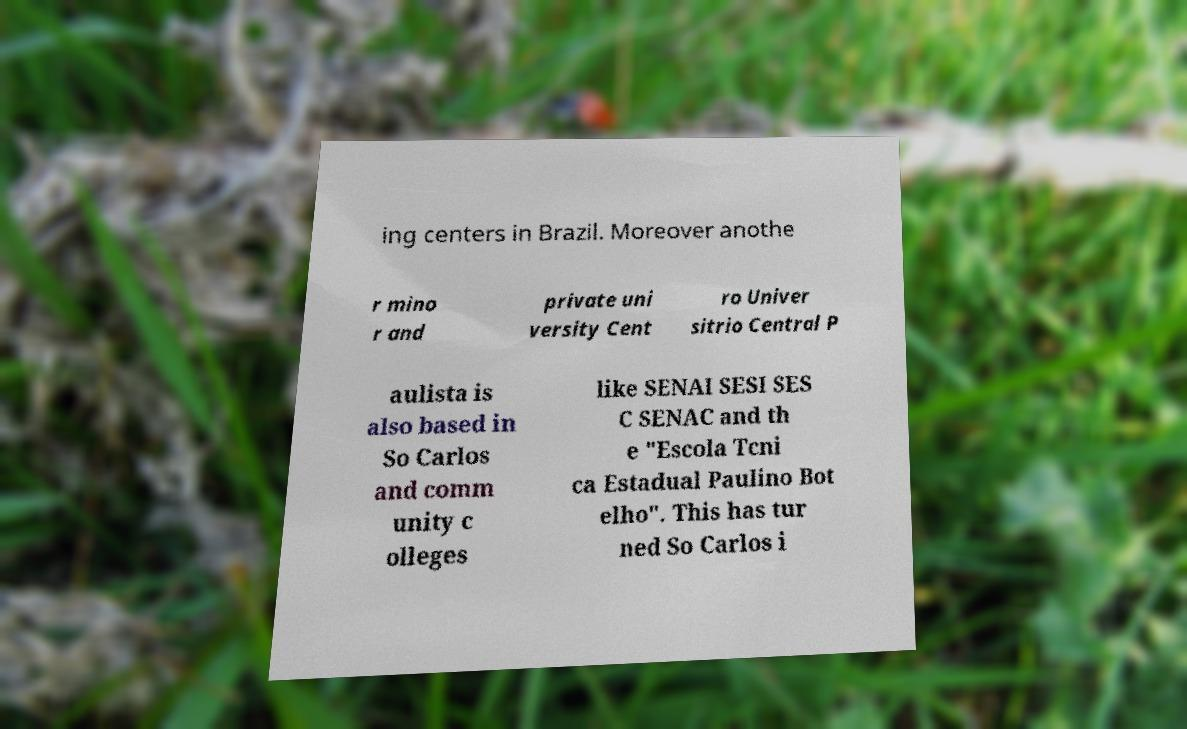Could you extract and type out the text from this image? ing centers in Brazil. Moreover anothe r mino r and private uni versity Cent ro Univer sitrio Central P aulista is also based in So Carlos and comm unity c olleges like SENAI SESI SES C SENAC and th e "Escola Tcni ca Estadual Paulino Bot elho". This has tur ned So Carlos i 